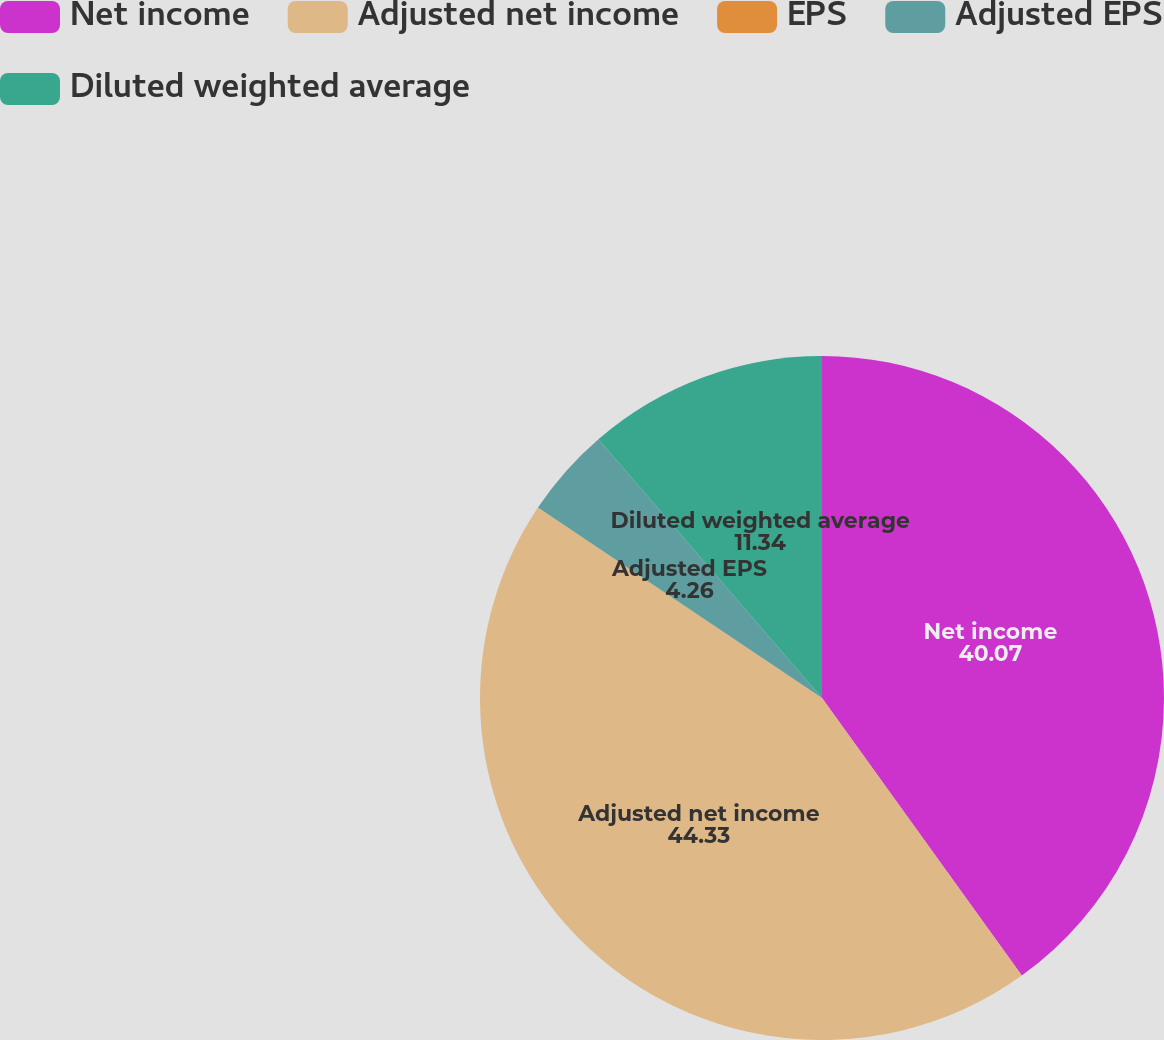Convert chart. <chart><loc_0><loc_0><loc_500><loc_500><pie_chart><fcel>Net income<fcel>Adjusted net income<fcel>EPS<fcel>Adjusted EPS<fcel>Diluted weighted average<nl><fcel>40.07%<fcel>44.33%<fcel>0.0%<fcel>4.26%<fcel>11.34%<nl></chart> 